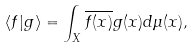<formula> <loc_0><loc_0><loc_500><loc_500>\langle f | g \rangle = \int _ { X } \overline { f ( x ) } { g ( x ) } d \mu ( x ) ,</formula> 